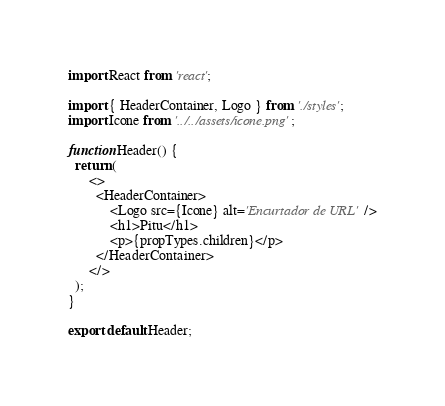<code> <loc_0><loc_0><loc_500><loc_500><_JavaScript_>import React from 'react';

import { HeaderContainer, Logo } from './styles';
import Icone from '../../assets/icone.png';

function Header() {
  return (
      <>
        <HeaderContainer>
            <Logo src={Icone} alt='Encurtador de URL' />
            <h1>Pitu</h1>
            <p>{propTypes.children}</p>
        </HeaderContainer>
      </>
  );
}

export default Header;</code> 